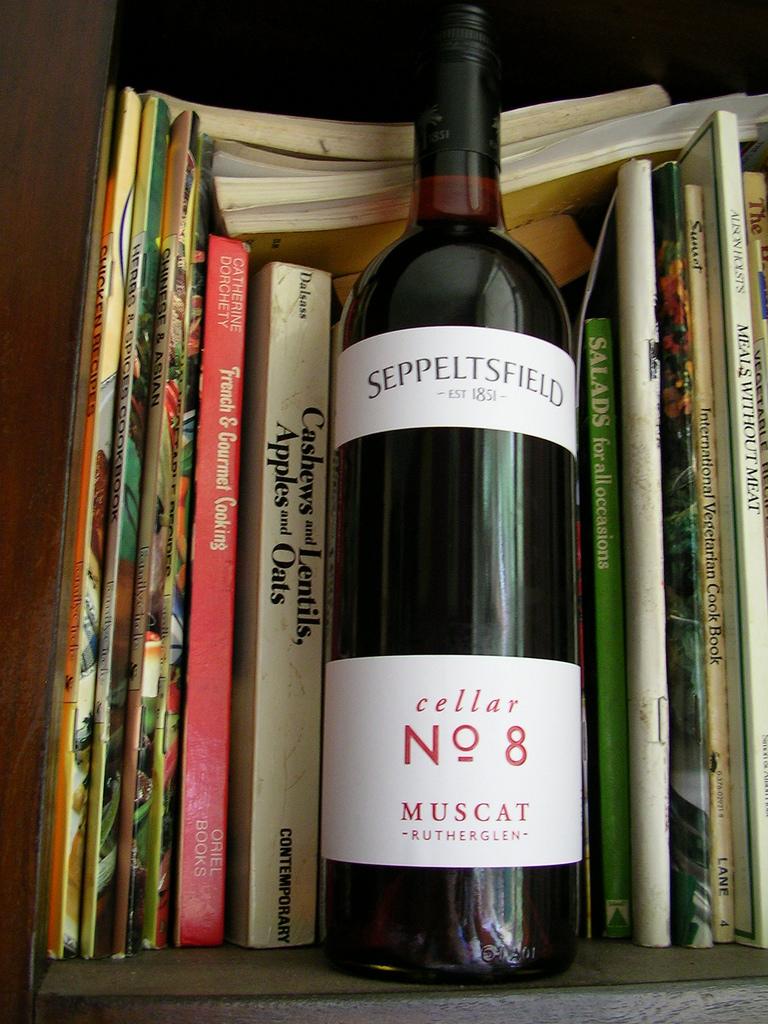What is the wine label?
Offer a terse response. Cellar no 8. Who is the author of french & gourmet cooking?
Ensure brevity in your answer.  Catherine dorchety. 